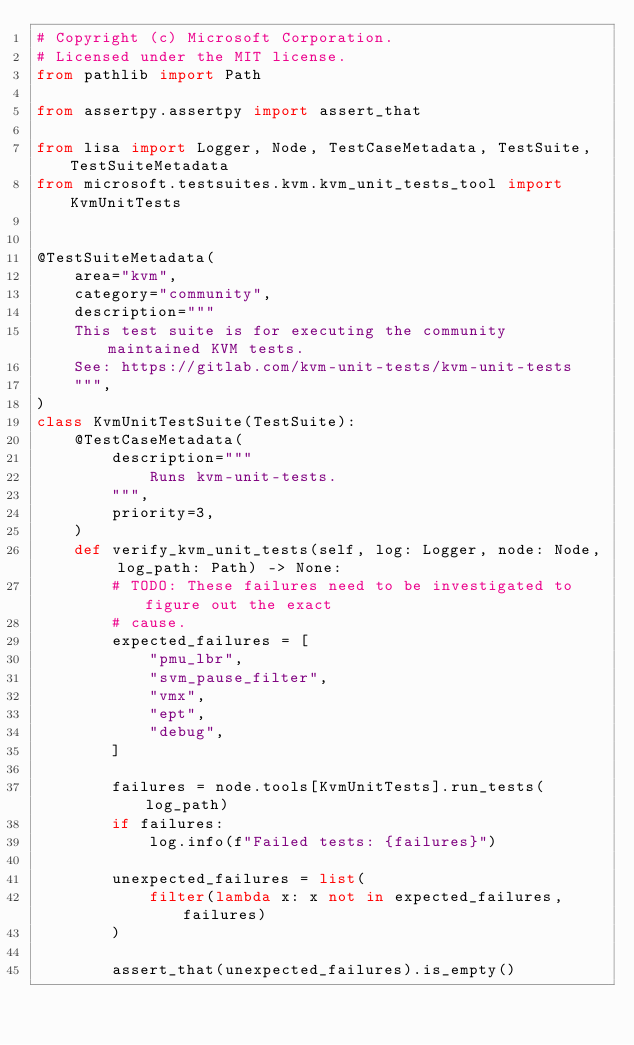<code> <loc_0><loc_0><loc_500><loc_500><_Python_># Copyright (c) Microsoft Corporation.
# Licensed under the MIT license.
from pathlib import Path

from assertpy.assertpy import assert_that

from lisa import Logger, Node, TestCaseMetadata, TestSuite, TestSuiteMetadata
from microsoft.testsuites.kvm.kvm_unit_tests_tool import KvmUnitTests


@TestSuiteMetadata(
    area="kvm",
    category="community",
    description="""
    This test suite is for executing the community maintained KVM tests.
    See: https://gitlab.com/kvm-unit-tests/kvm-unit-tests
    """,
)
class KvmUnitTestSuite(TestSuite):
    @TestCaseMetadata(
        description="""
            Runs kvm-unit-tests.
        """,
        priority=3,
    )
    def verify_kvm_unit_tests(self, log: Logger, node: Node, log_path: Path) -> None:
        # TODO: These failures need to be investigated to figure out the exact
        # cause.
        expected_failures = [
            "pmu_lbr",
            "svm_pause_filter",
            "vmx",
            "ept",
            "debug",
        ]

        failures = node.tools[KvmUnitTests].run_tests(log_path)
        if failures:
            log.info(f"Failed tests: {failures}")

        unexpected_failures = list(
            filter(lambda x: x not in expected_failures, failures)
        )

        assert_that(unexpected_failures).is_empty()
</code> 